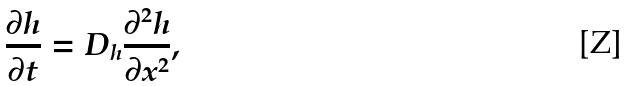<formula> <loc_0><loc_0><loc_500><loc_500>\frac { \partial h } { \partial t } = D _ { h } \frac { \partial ^ { 2 } h } { \partial x ^ { 2 } } ,</formula> 